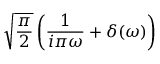<formula> <loc_0><loc_0><loc_500><loc_500>{ \sqrt { \frac { \pi } { 2 } } } \left ( { \frac { 1 } { i \pi \omega } } + \delta ( \omega ) \right )</formula> 